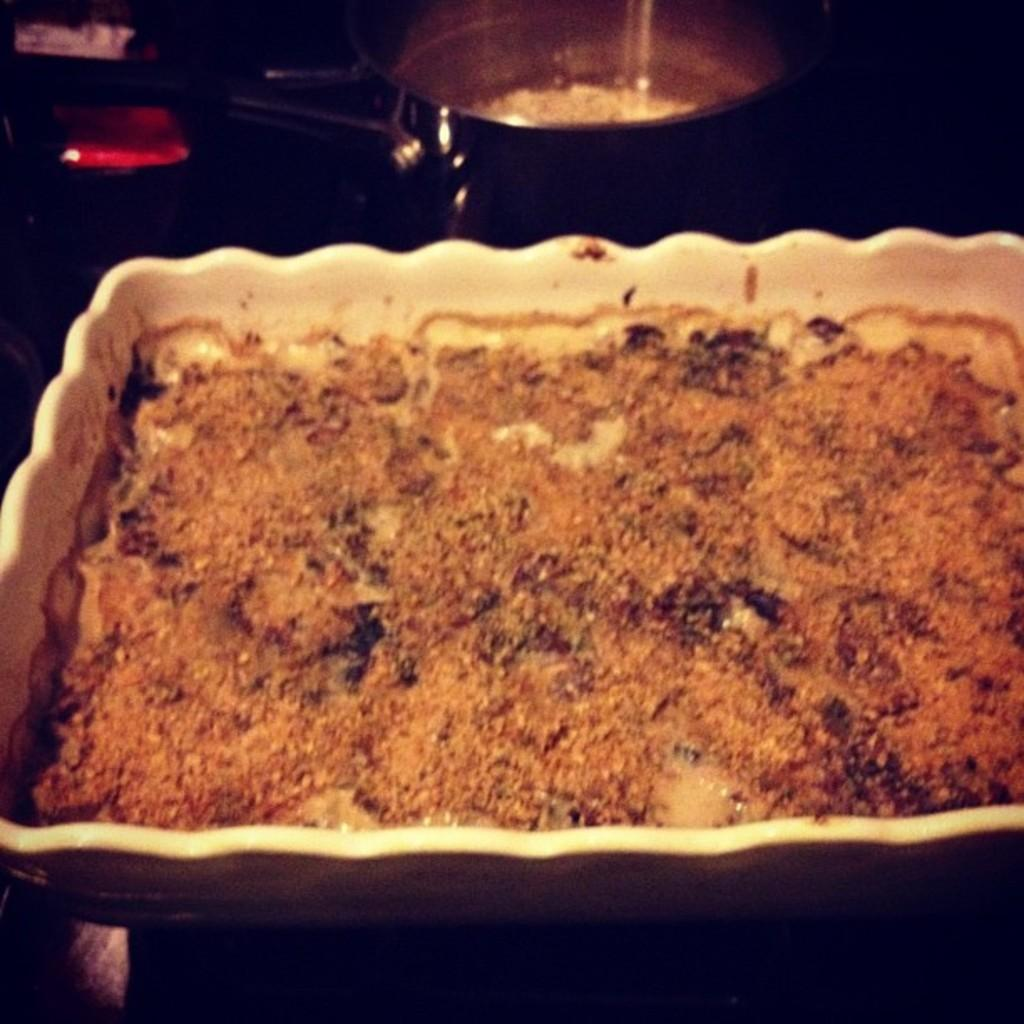What type of yam is the ghost holding on the shelf in the image? There is no image provided, and therefore no ghost, shelf, or yam can be observed. 